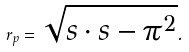<formula> <loc_0><loc_0><loc_500><loc_500>r _ { p } = \sqrt { { s } \cdot { s } - { \pi } ^ { 2 } } .</formula> 